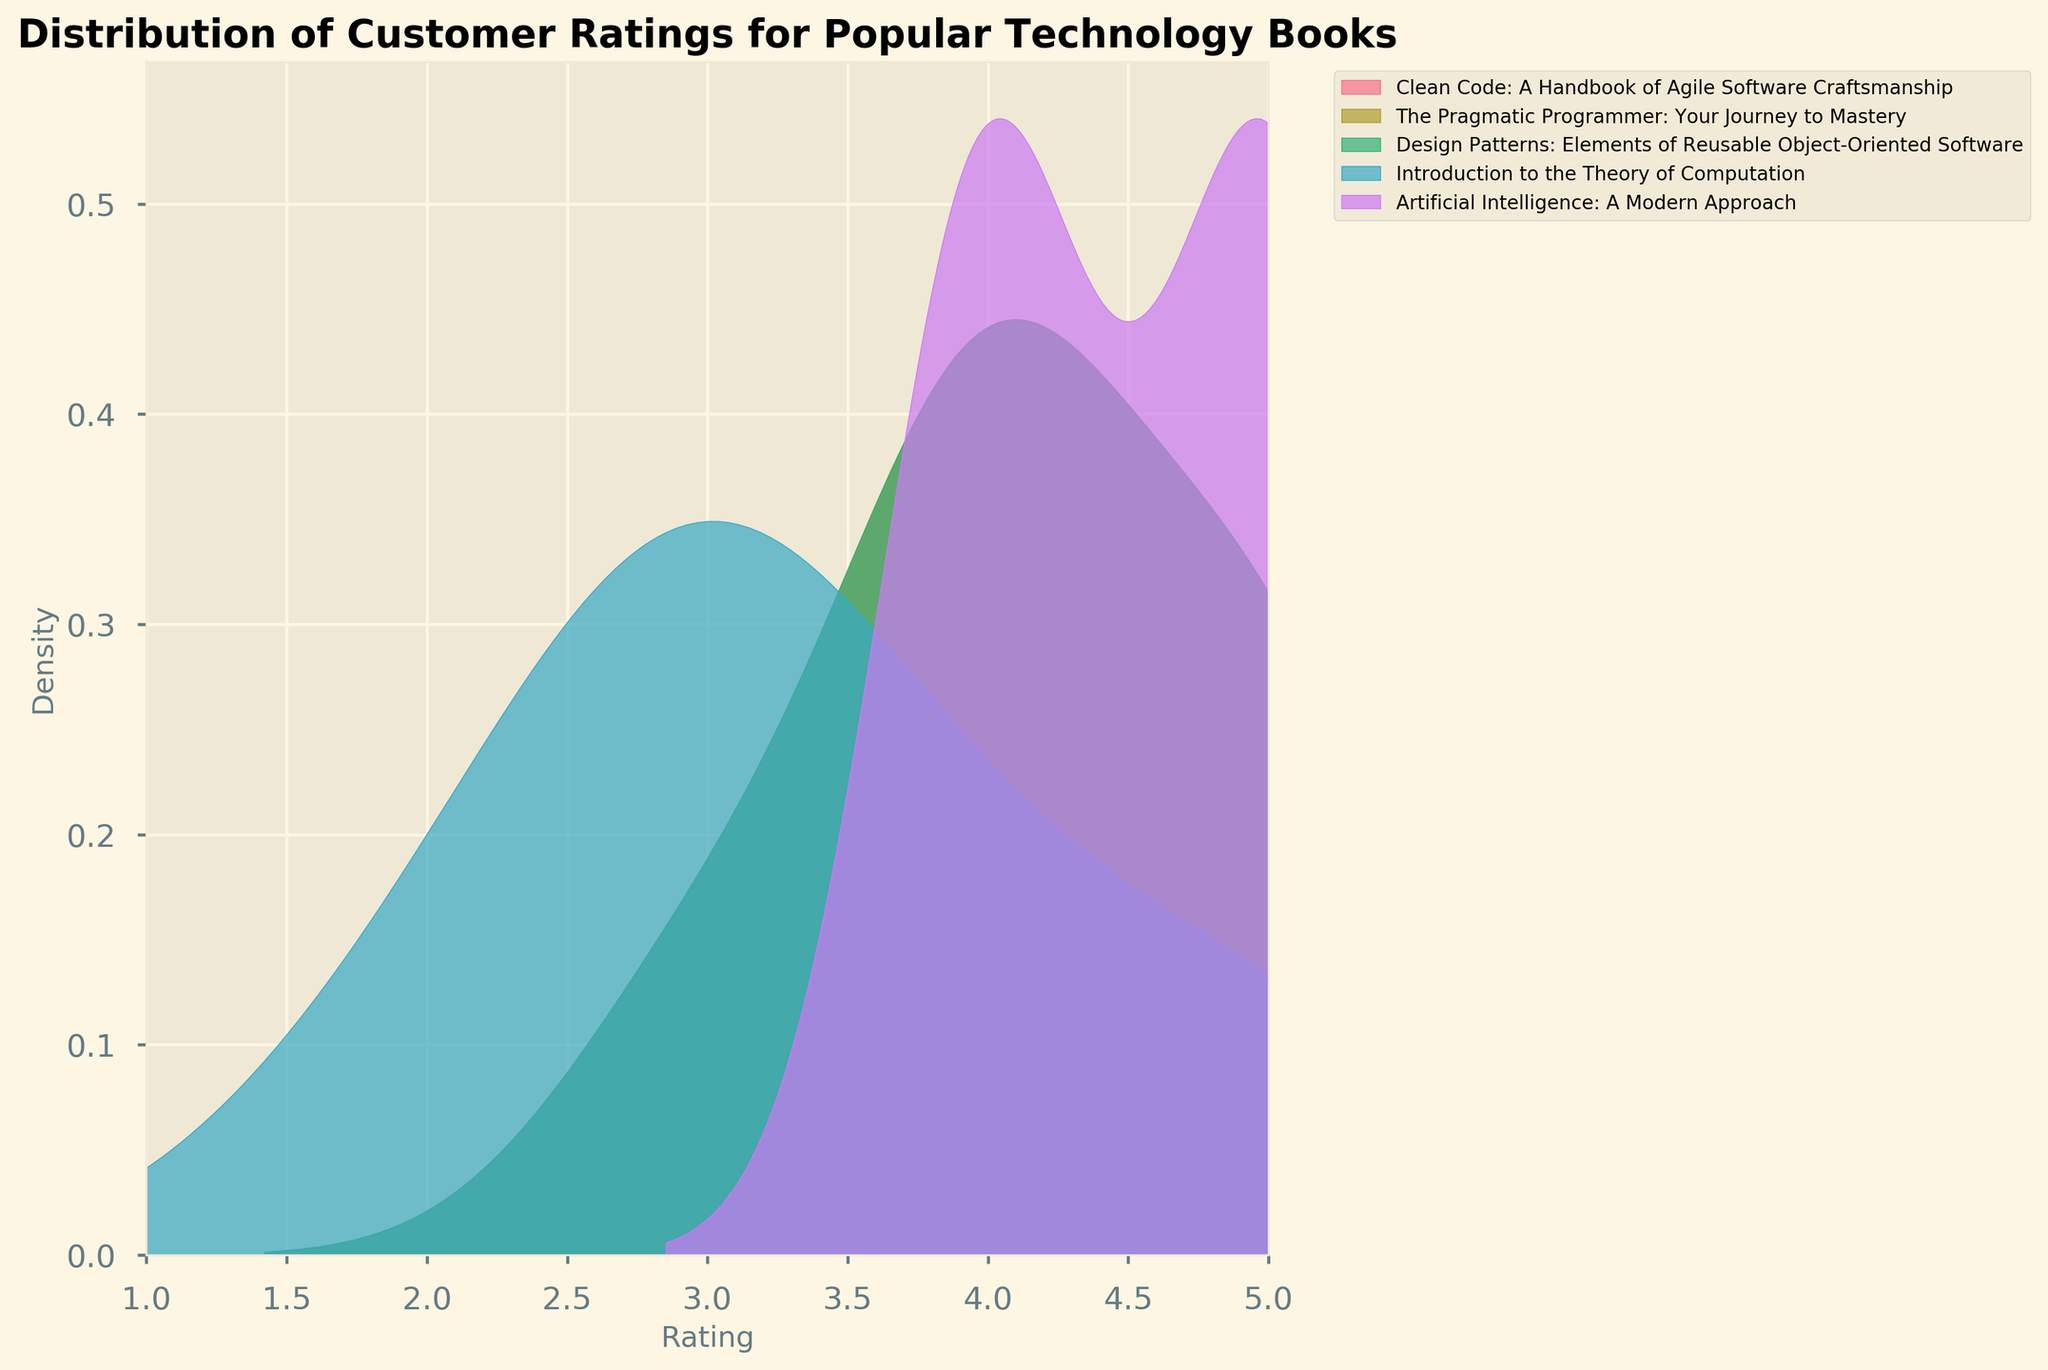What is the title of the figure? The title is prominently displayed at the top of the figure. It directly describes what the plot represents. The title reads "Distribution of Customer Ratings for Popular Technology Books."
Answer: Distribution of Customer Ratings for Popular Technology Books What is the range of ratings displayed on the x-axis? The x-axis depicts the range of customer ratings for the books, which can be inferred directly from the axis labels. The ratings range from 1 to 5.
Answer: 1 to 5 Which book has the highest peak in the density plot? By observing the density plot, the book with the highest peak can be identified as the one with the tallest curve. In this case, "Artificial Intelligence: A Modern Approach" shows the highest peak.
Answer: Artificial Intelligence: A Modern Approach How many distinct books are represented in the density plot? Each book is represented by a different colored curve in the plot. Counting the number of different curves (or checking the legend) will give the number of distinct books. There are six distinct books.
Answer: 6 Which book has the most evenly distributed ratings? A book with evenly distributed ratings will have a density plot that does not peak sharply at any particular point but is spread out more evenly across the rating range. "Introduction to the Theory of Computation" appears to have a more evenly distributed curve.
Answer: Introduction to the Theory of Computation What rating is most common for "Clean Code: A Handbook of Agile Software Craftsmanship"? By observing the peak of the density plot for "Clean Code: A Handbook of Agile Software Craftsmanship," we can identify the most common rating. The peak occurs at rating 4.
Answer: 4 Compare the density peaks of "Design Patterns: Elements of Reusable Object-Oriented Software" and "The Pragmatic Programmer: Your Journey to Mastery." Which has a higher peak? By comparing the height of the peaks for the two books on their density curves, we can see that "Design Patterns: Elements of Reusable Object-Oriented Software" has a higher peak.
Answer: Design Patterns: Elements of Reusable Object-Oriented Software Which two books have the closest distribution of ratings? To determine which two books have the closest distribution, we compare the shape and location of the density curves. "Clean Code: A Handbook of Agile Software Craftsmanship" and "The Pragmatic Programmer: Your Journey to Mastery" have similar distributions with peaks at rating 4 and similar spread.
Answer: Clean Code: A Handbook of Agile Software Craftsmanship and The Pragmatic Programmer: Your Journey to Mastery What does a higher peak in the density curve signify about a book's ratings? A higher peak in the density curve indicates that a large proportion of the ratings for that book are concentrated around a specific rating value, implying a higher frequency of that particular rating. This suggests that many customers gave a very similar rating to the book.
Answer: Higher frequency of a specific rating 